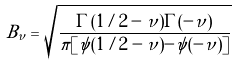Convert formula to latex. <formula><loc_0><loc_0><loc_500><loc_500>B _ { \nu } = \sqrt { \frac { \Gamma ( 1 / 2 - \nu ) \Gamma ( - \nu ) } { \pi [ \psi ( 1 / 2 - \nu ) - \psi ( - \nu ) ] } }</formula> 